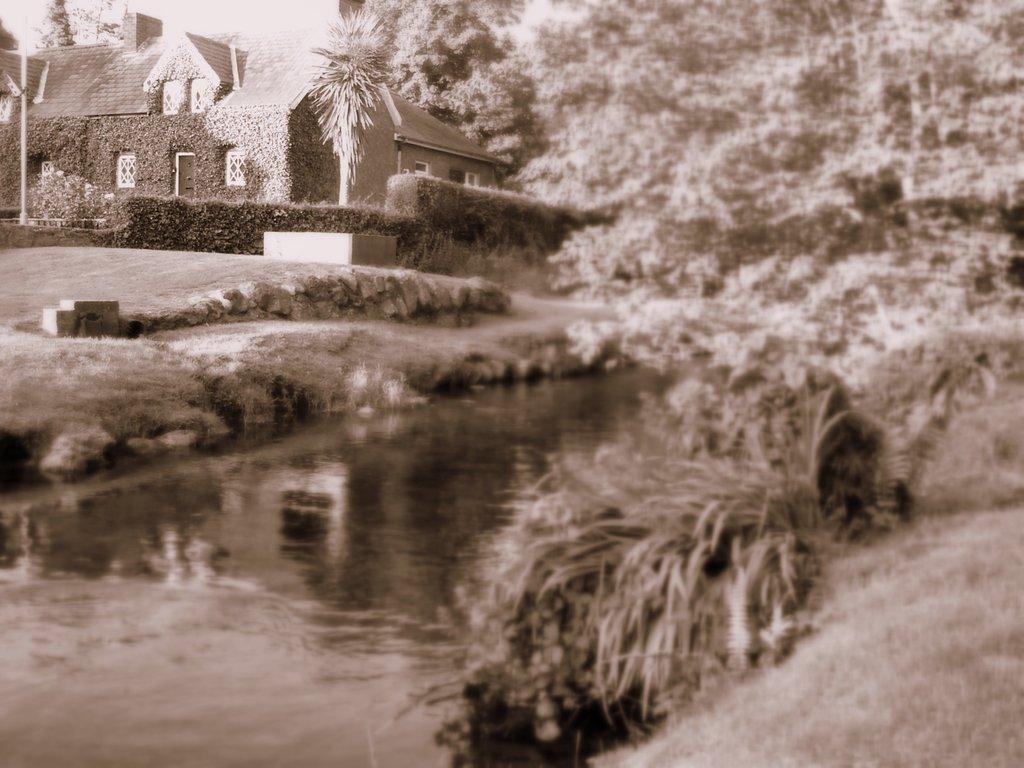Describe this image in one or two sentences. In this black and white image there is a building with trees and plants. At the center of the image there is a river. 